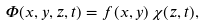Convert formula to latex. <formula><loc_0><loc_0><loc_500><loc_500>\Phi ( x , y , z , t ) = f ( x , y ) \, \chi ( z , t ) ,</formula> 